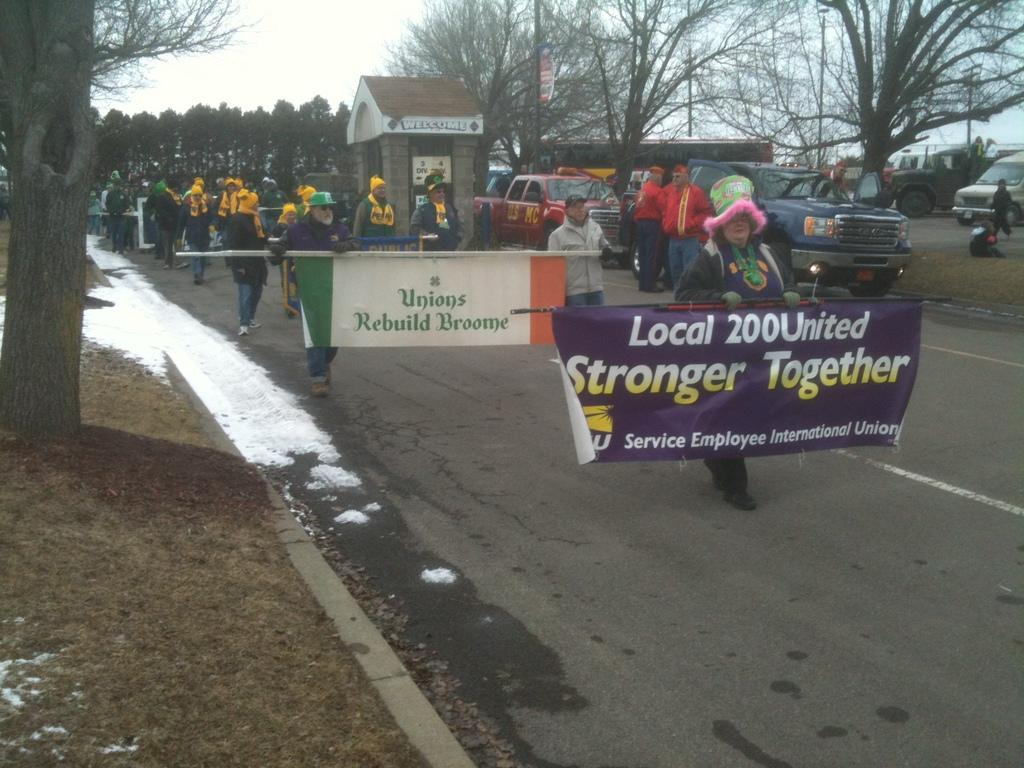<image>
Render a clear and concise summary of the photo. Parade for the Local 200United they say they are stronger together. 